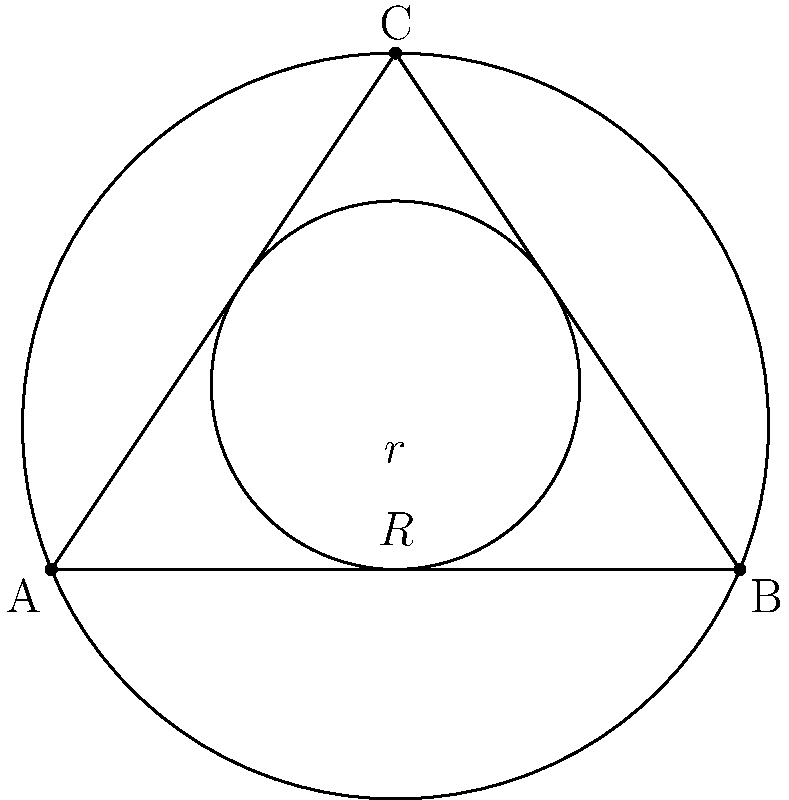In the diagram, triangle ABC is inscribed in a circle with radius R and circumscribes a circle with radius r. If the area of triangle ABC is 100 square units, what is the value of $\frac{R}{r}$? Let's approach this step-by-step:

1) For any triangle, we have the relationship: $\text{Area} = rs$, where $r$ is the inradius and $s$ is the semi-perimeter.

2) We're also given that $\text{Area} = \frac{abc}{4R}$, where $a$, $b$, and $c$ are the side lengths of the triangle, and $R$ is the circumradius.

3) Equating these two expressions for area:

   $$rs = \frac{abc}{4R}$$

4) We're given that the area is 100 square units. So:

   $$100 = rs = \frac{abc}{4R}$$

5) From this, we can derive:

   $$\frac{R}{r} = \frac{abc}{400s}$$

6) Now, recall the formula for a triangle's semi-perimeter: $s = \frac{a+b+c}{2}$

7) Substituting this into our equation:

   $$\frac{R}{r} = \frac{abc}{200(a+b+c)}$$

8) This ratio $\frac{abc}{a+b+c}$ is always equal to 2 for any triangle. This is known as the "2R theorem" in geometry.

Therefore, we can conclude:

   $$\frac{R}{r} = \frac{2}{200} = \frac{1}{100}$$
Answer: $\frac{1}{100}$ 